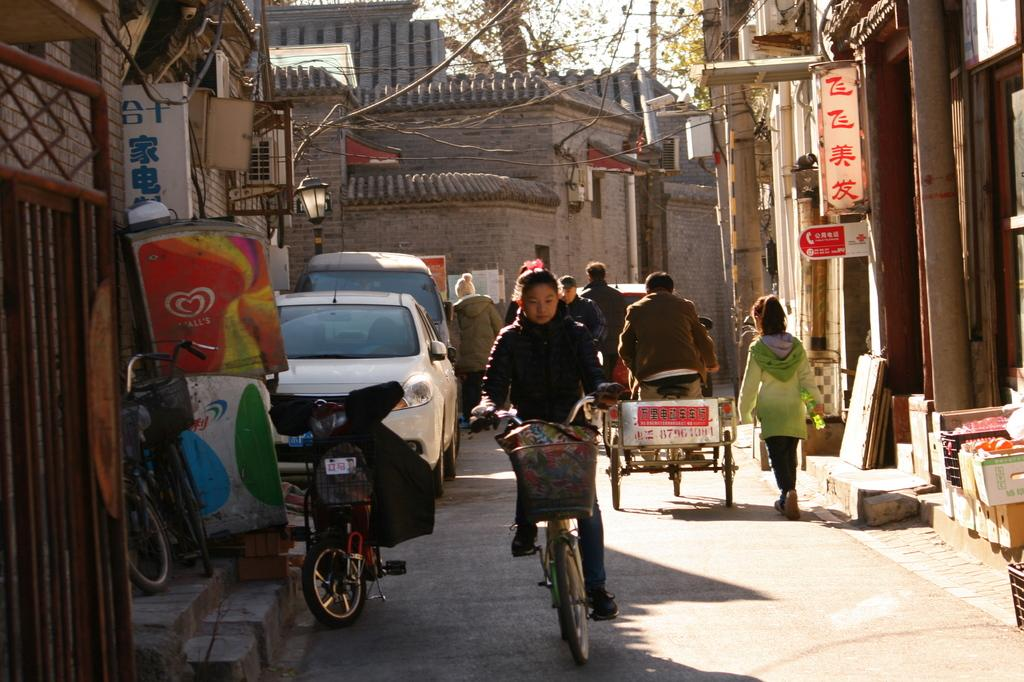What is the lady in the image doing? The lady is riding a bicycle in the image. What else can be seen in the image besides the lady on the bicycle? There are other vehicles, houses, buildings, and a tree in the image. Can you describe the buildings in the image? Some of the buildings have boards in the image. Are there any jellyfish visible in the image? No, there are no jellyfish present in the image. What is the name of the downtown area in the image? The image does not specify a downtown area, and there is no indication of a downtown area in the image. 